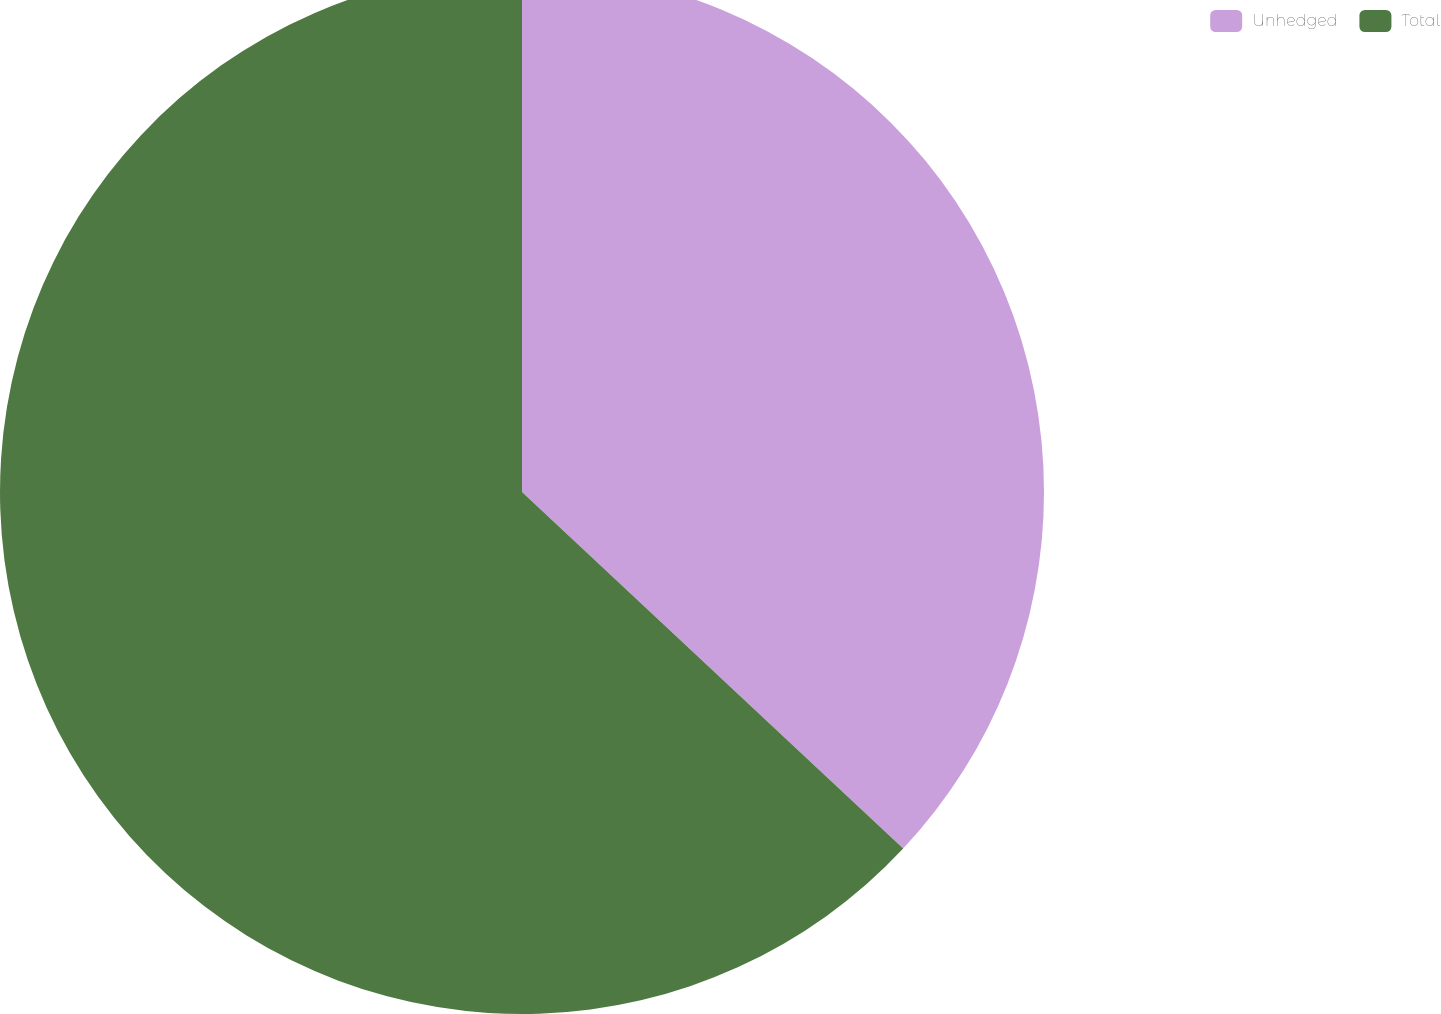<chart> <loc_0><loc_0><loc_500><loc_500><pie_chart><fcel>Unhedged<fcel>Total<nl><fcel>36.97%<fcel>63.03%<nl></chart> 